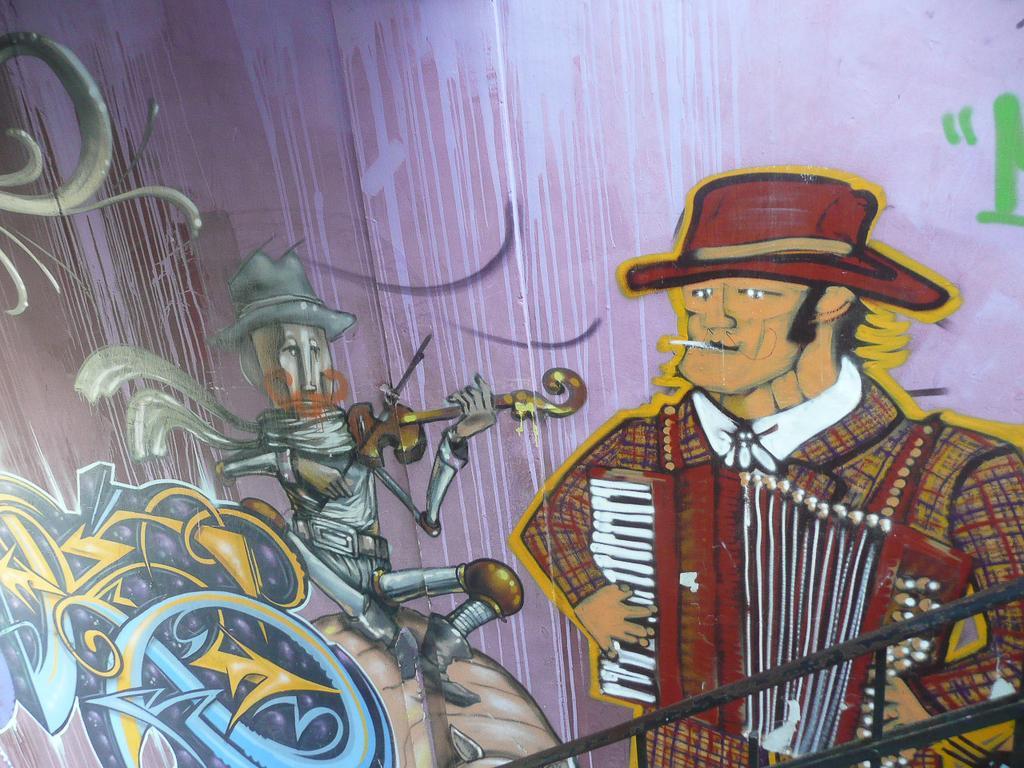Please provide a concise description of this image. In the picture we can see a painting with a man standing and holding a musical instrument and playing it and he is with a hat and beside him we can see a doll holding a musical instrument and playing it and beside it we can see some designs. 